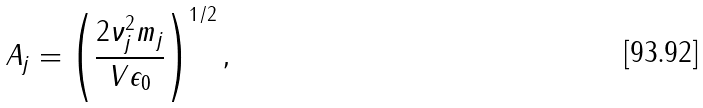<formula> <loc_0><loc_0><loc_500><loc_500>A _ { j } = \left ( \frac { 2 \nu ^ { 2 } _ { j } m _ { j } } { V \epsilon _ { 0 } } \right ) ^ { 1 / 2 } ,</formula> 